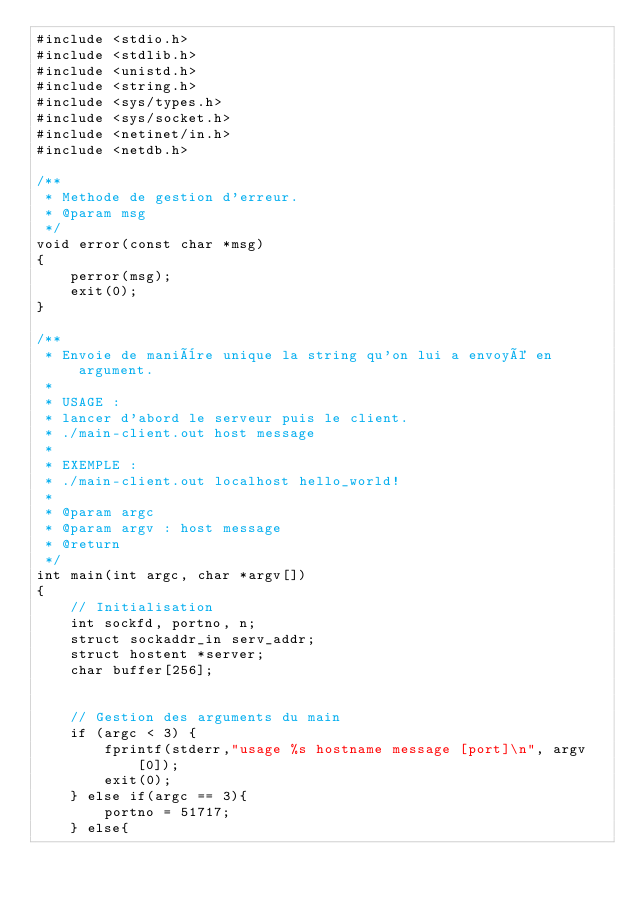<code> <loc_0><loc_0><loc_500><loc_500><_C_>#include <stdio.h>
#include <stdlib.h>
#include <unistd.h>
#include <string.h>
#include <sys/types.h>
#include <sys/socket.h>
#include <netinet/in.h>
#include <netdb.h>

/**
 * Methode de gestion d'erreur.
 * @param msg
 */
void error(const char *msg)
{
    perror(msg);
    exit(0);
}

/**
 * Envoie de manière unique la string qu'on lui a envoyé en argument.
 *
 * USAGE :
 * lancer d'abord le serveur puis le client.
 * ./main-client.out host message
 *
 * EXEMPLE :
 * ./main-client.out localhost hello_world!
 *
 * @param argc
 * @param argv : host message
 * @return
 */
int main(int argc, char *argv[])
{
    // Initialisation
    int sockfd, portno, n;
    struct sockaddr_in serv_addr;
    struct hostent *server;
    char buffer[256];


    // Gestion des arguments du main
    if (argc < 3) {
        fprintf(stderr,"usage %s hostname message [port]\n", argv[0]);
        exit(0);
    } else if(argc == 3){
        portno = 51717;
    } else{</code> 